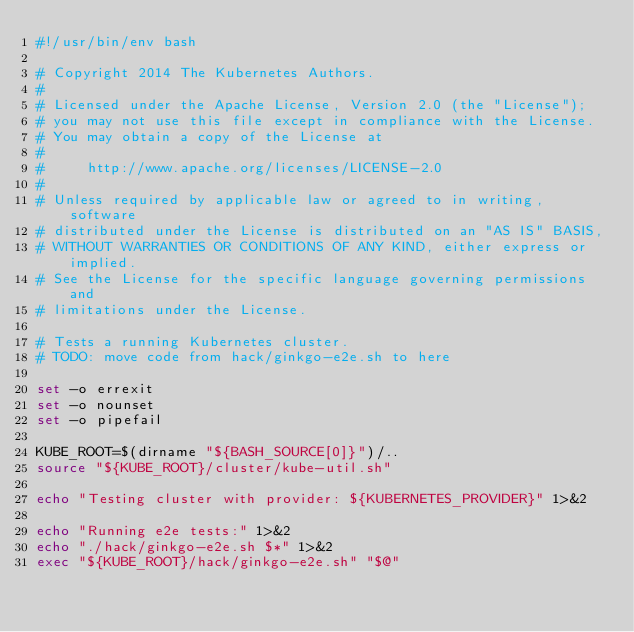<code> <loc_0><loc_0><loc_500><loc_500><_Bash_>#!/usr/bin/env bash

# Copyright 2014 The Kubernetes Authors.
#
# Licensed under the Apache License, Version 2.0 (the "License");
# you may not use this file except in compliance with the License.
# You may obtain a copy of the License at
#
#     http://www.apache.org/licenses/LICENSE-2.0
#
# Unless required by applicable law or agreed to in writing, software
# distributed under the License is distributed on an "AS IS" BASIS,
# WITHOUT WARRANTIES OR CONDITIONS OF ANY KIND, either express or implied.
# See the License for the specific language governing permissions and
# limitations under the License.

# Tests a running Kubernetes cluster.
# TODO: move code from hack/ginkgo-e2e.sh to here

set -o errexit
set -o nounset
set -o pipefail

KUBE_ROOT=$(dirname "${BASH_SOURCE[0]}")/..
source "${KUBE_ROOT}/cluster/kube-util.sh"

echo "Testing cluster with provider: ${KUBERNETES_PROVIDER}" 1>&2

echo "Running e2e tests:" 1>&2
echo "./hack/ginkgo-e2e.sh $*" 1>&2
exec "${KUBE_ROOT}/hack/ginkgo-e2e.sh" "$@"
</code> 